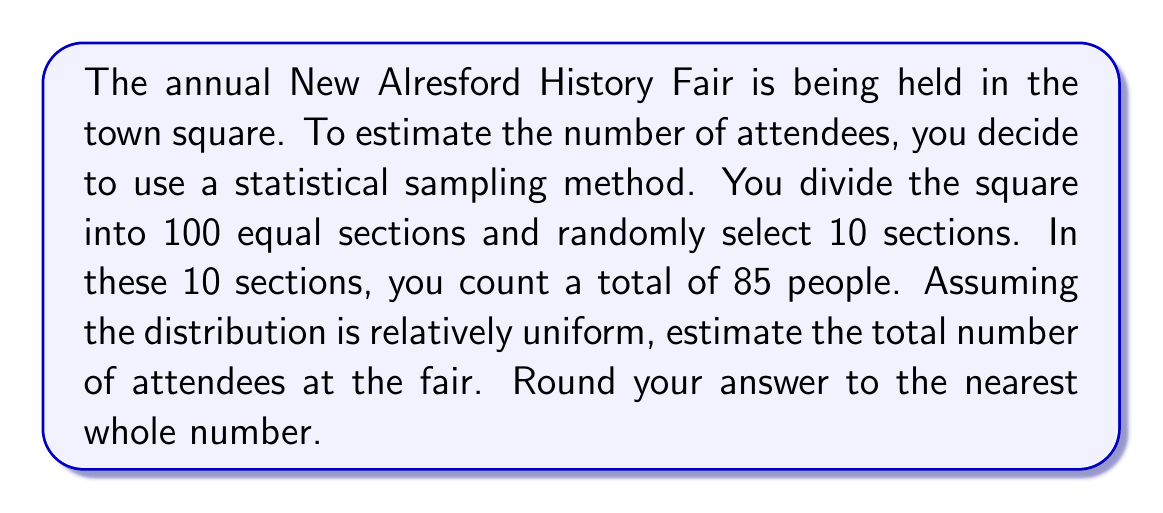Provide a solution to this math problem. Let's approach this step-by-step:

1) First, we need to understand what our sample represents:
   - The town square is divided into 100 sections
   - We randomly selected 10 sections
   - In these 10 sections, we counted 85 people

2) To estimate the total number of attendees, we can use the following proportion:
   
   $$\frac{\text{People in sample}}{\text{Sections in sample}} = \frac{\text{Total people}}{\text{Total sections}}$$

3) Let's plug in the numbers we know:
   
   $$\frac{85}{10} = \frac{x}{100}$$

   Where $x$ is the estimated total number of attendees.

4) To solve for $x$, we can cross-multiply:
   
   $$85 * 100 = 10x$$

5) Now, let's solve the equation:
   
   $$8500 = 10x$$
   $$x = 8500 / 10 = 850$$

6) The question asks to round to the nearest whole number, but 850 is already a whole number.

Therefore, our estimate for the total number of attendees at the New Alresford History Fair is 850 people.
Answer: 850 people 